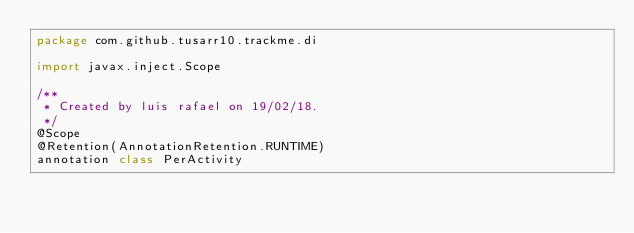<code> <loc_0><loc_0><loc_500><loc_500><_Kotlin_>package com.github.tusarr10.trackme.di

import javax.inject.Scope

/**
 * Created by luis rafael on 19/02/18.
 */
@Scope
@Retention(AnnotationRetention.RUNTIME)
annotation class PerActivity</code> 